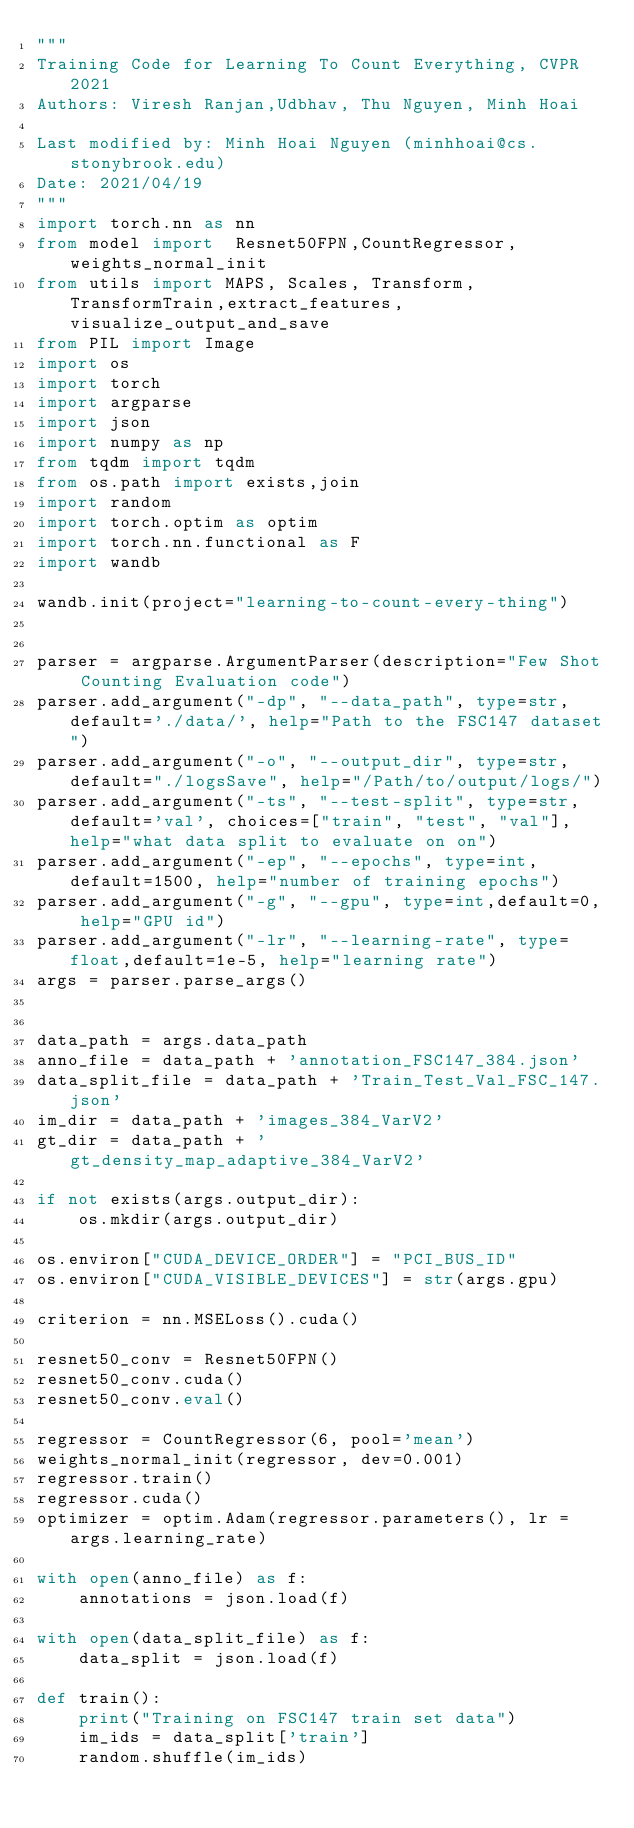Convert code to text. <code><loc_0><loc_0><loc_500><loc_500><_Python_>"""
Training Code for Learning To Count Everything, CVPR 2021
Authors: Viresh Ranjan,Udbhav, Thu Nguyen, Minh Hoai

Last modified by: Minh Hoai Nguyen (minhhoai@cs.stonybrook.edu)
Date: 2021/04/19
"""
import torch.nn as nn
from model import  Resnet50FPN,CountRegressor,weights_normal_init
from utils import MAPS, Scales, Transform,TransformTrain,extract_features, visualize_output_and_save
from PIL import Image
import os
import torch
import argparse
import json
import numpy as np
from tqdm import tqdm
from os.path import exists,join
import random
import torch.optim as optim
import torch.nn.functional as F
import wandb

wandb.init(project="learning-to-count-every-thing")


parser = argparse.ArgumentParser(description="Few Shot Counting Evaluation code")
parser.add_argument("-dp", "--data_path", type=str, default='./data/', help="Path to the FSC147 dataset")
parser.add_argument("-o", "--output_dir", type=str,default="./logsSave", help="/Path/to/output/logs/")
parser.add_argument("-ts", "--test-split", type=str, default='val', choices=["train", "test", "val"], help="what data split to evaluate on on")
parser.add_argument("-ep", "--epochs", type=int,default=1500, help="number of training epochs")
parser.add_argument("-g", "--gpu", type=int,default=0, help="GPU id")
parser.add_argument("-lr", "--learning-rate", type=float,default=1e-5, help="learning rate")
args = parser.parse_args()


data_path = args.data_path
anno_file = data_path + 'annotation_FSC147_384.json'
data_split_file = data_path + 'Train_Test_Val_FSC_147.json'
im_dir = data_path + 'images_384_VarV2'
gt_dir = data_path + 'gt_density_map_adaptive_384_VarV2'

if not exists(args.output_dir):
    os.mkdir(args.output_dir)

os.environ["CUDA_DEVICE_ORDER"] = "PCI_BUS_ID"
os.environ["CUDA_VISIBLE_DEVICES"] = str(args.gpu)

criterion = nn.MSELoss().cuda()

resnet50_conv = Resnet50FPN()
resnet50_conv.cuda()
resnet50_conv.eval()

regressor = CountRegressor(6, pool='mean')
weights_normal_init(regressor, dev=0.001)
regressor.train()
regressor.cuda()
optimizer = optim.Adam(regressor.parameters(), lr = args.learning_rate)

with open(anno_file) as f:
    annotations = json.load(f)

with open(data_split_file) as f:
    data_split = json.load(f)

def train():
    print("Training on FSC147 train set data")
    im_ids = data_split['train']
    random.shuffle(im_ids)</code> 